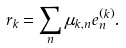Convert formula to latex. <formula><loc_0><loc_0><loc_500><loc_500>\ r _ { k } = \sum _ { n } \mu _ { k , n } e ^ { ( k ) } _ { n } .</formula> 